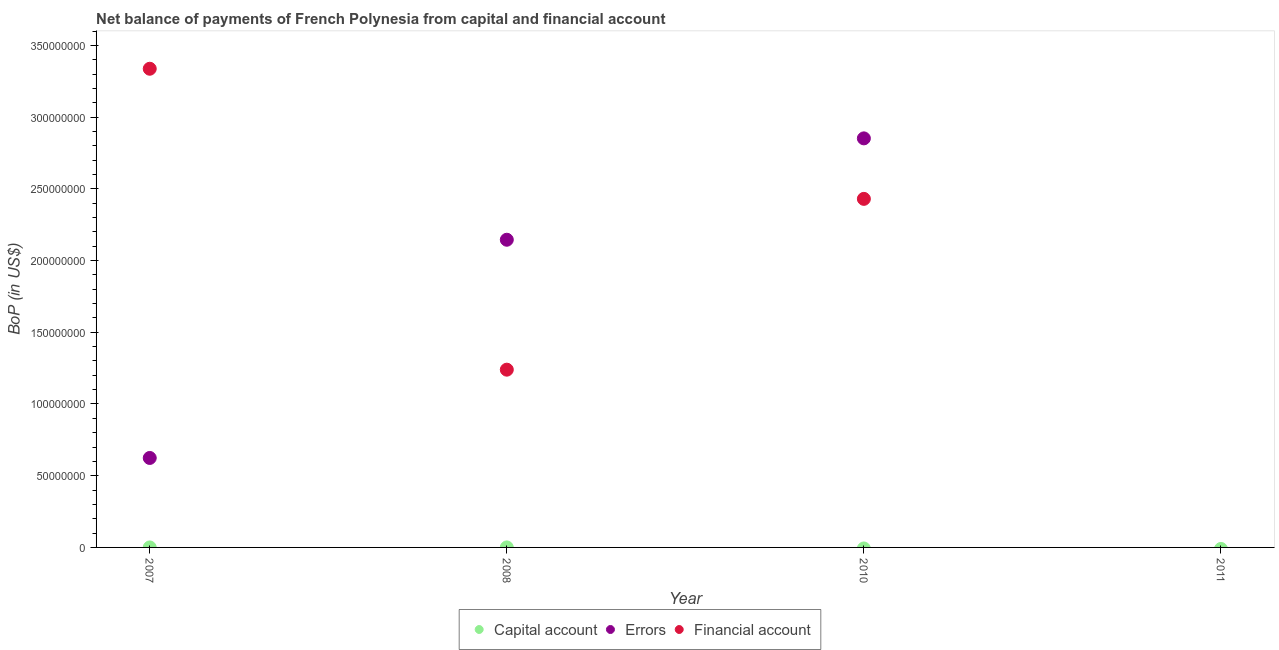Is the number of dotlines equal to the number of legend labels?
Your answer should be compact. No. Across all years, what is the maximum amount of financial account?
Keep it short and to the point. 3.34e+08. Across all years, what is the minimum amount of financial account?
Give a very brief answer. 0. What is the total amount of net capital account in the graph?
Make the answer very short. 8350.98. What is the difference between the amount of financial account in 2008 and that in 2010?
Offer a very short reply. -1.19e+08. What is the difference between the amount of financial account in 2007 and the amount of net capital account in 2010?
Give a very brief answer. 3.34e+08. What is the average amount of errors per year?
Give a very brief answer. 1.41e+08. In the year 2008, what is the difference between the amount of financial account and amount of errors?
Your answer should be very brief. -9.06e+07. What is the ratio of the amount of financial account in 2008 to that in 2010?
Offer a terse response. 0.51. What is the difference between the highest and the second highest amount of errors?
Your answer should be compact. 7.07e+07. What is the difference between the highest and the lowest amount of financial account?
Make the answer very short. 3.34e+08. Is the sum of the amount of errors in 2007 and 2010 greater than the maximum amount of financial account across all years?
Ensure brevity in your answer.  Yes. Does the amount of errors monotonically increase over the years?
Provide a succinct answer. No. Is the amount of errors strictly greater than the amount of net capital account over the years?
Your answer should be very brief. No. How many years are there in the graph?
Offer a very short reply. 4. Does the graph contain any zero values?
Make the answer very short. Yes. Does the graph contain grids?
Offer a very short reply. No. What is the title of the graph?
Keep it short and to the point. Net balance of payments of French Polynesia from capital and financial account. What is the label or title of the X-axis?
Keep it short and to the point. Year. What is the label or title of the Y-axis?
Your answer should be very brief. BoP (in US$). What is the BoP (in US$) in Errors in 2007?
Keep it short and to the point. 6.24e+07. What is the BoP (in US$) in Financial account in 2007?
Offer a very short reply. 3.34e+08. What is the BoP (in US$) in Capital account in 2008?
Your answer should be very brief. 8350.98. What is the BoP (in US$) in Errors in 2008?
Your answer should be very brief. 2.15e+08. What is the BoP (in US$) of Financial account in 2008?
Ensure brevity in your answer.  1.24e+08. What is the BoP (in US$) of Errors in 2010?
Offer a terse response. 2.85e+08. What is the BoP (in US$) of Financial account in 2010?
Ensure brevity in your answer.  2.43e+08. What is the BoP (in US$) of Capital account in 2011?
Ensure brevity in your answer.  0. What is the BoP (in US$) in Financial account in 2011?
Your answer should be very brief. 0. Across all years, what is the maximum BoP (in US$) of Capital account?
Your response must be concise. 8350.98. Across all years, what is the maximum BoP (in US$) in Errors?
Make the answer very short. 2.85e+08. Across all years, what is the maximum BoP (in US$) of Financial account?
Give a very brief answer. 3.34e+08. Across all years, what is the minimum BoP (in US$) of Capital account?
Give a very brief answer. 0. Across all years, what is the minimum BoP (in US$) in Errors?
Give a very brief answer. 0. What is the total BoP (in US$) in Capital account in the graph?
Offer a very short reply. 8350.98. What is the total BoP (in US$) in Errors in the graph?
Your answer should be very brief. 5.62e+08. What is the total BoP (in US$) in Financial account in the graph?
Give a very brief answer. 7.01e+08. What is the difference between the BoP (in US$) of Errors in 2007 and that in 2008?
Provide a succinct answer. -1.52e+08. What is the difference between the BoP (in US$) in Financial account in 2007 and that in 2008?
Make the answer very short. 2.10e+08. What is the difference between the BoP (in US$) of Errors in 2007 and that in 2010?
Keep it short and to the point. -2.23e+08. What is the difference between the BoP (in US$) in Financial account in 2007 and that in 2010?
Offer a very short reply. 9.07e+07. What is the difference between the BoP (in US$) in Errors in 2008 and that in 2010?
Keep it short and to the point. -7.07e+07. What is the difference between the BoP (in US$) in Financial account in 2008 and that in 2010?
Ensure brevity in your answer.  -1.19e+08. What is the difference between the BoP (in US$) in Errors in 2007 and the BoP (in US$) in Financial account in 2008?
Provide a short and direct response. -6.16e+07. What is the difference between the BoP (in US$) in Errors in 2007 and the BoP (in US$) in Financial account in 2010?
Offer a very short reply. -1.81e+08. What is the difference between the BoP (in US$) in Capital account in 2008 and the BoP (in US$) in Errors in 2010?
Your response must be concise. -2.85e+08. What is the difference between the BoP (in US$) of Capital account in 2008 and the BoP (in US$) of Financial account in 2010?
Keep it short and to the point. -2.43e+08. What is the difference between the BoP (in US$) in Errors in 2008 and the BoP (in US$) in Financial account in 2010?
Provide a succinct answer. -2.85e+07. What is the average BoP (in US$) of Capital account per year?
Provide a succinct answer. 2087.74. What is the average BoP (in US$) in Errors per year?
Your answer should be compact. 1.41e+08. What is the average BoP (in US$) of Financial account per year?
Make the answer very short. 1.75e+08. In the year 2007, what is the difference between the BoP (in US$) of Errors and BoP (in US$) of Financial account?
Keep it short and to the point. -2.71e+08. In the year 2008, what is the difference between the BoP (in US$) of Capital account and BoP (in US$) of Errors?
Give a very brief answer. -2.15e+08. In the year 2008, what is the difference between the BoP (in US$) of Capital account and BoP (in US$) of Financial account?
Provide a short and direct response. -1.24e+08. In the year 2008, what is the difference between the BoP (in US$) in Errors and BoP (in US$) in Financial account?
Provide a succinct answer. 9.06e+07. In the year 2010, what is the difference between the BoP (in US$) of Errors and BoP (in US$) of Financial account?
Offer a very short reply. 4.22e+07. What is the ratio of the BoP (in US$) of Errors in 2007 to that in 2008?
Offer a terse response. 0.29. What is the ratio of the BoP (in US$) in Financial account in 2007 to that in 2008?
Ensure brevity in your answer.  2.69. What is the ratio of the BoP (in US$) of Errors in 2007 to that in 2010?
Offer a very short reply. 0.22. What is the ratio of the BoP (in US$) in Financial account in 2007 to that in 2010?
Offer a terse response. 1.37. What is the ratio of the BoP (in US$) in Errors in 2008 to that in 2010?
Provide a short and direct response. 0.75. What is the ratio of the BoP (in US$) of Financial account in 2008 to that in 2010?
Your answer should be compact. 0.51. What is the difference between the highest and the second highest BoP (in US$) of Errors?
Give a very brief answer. 7.07e+07. What is the difference between the highest and the second highest BoP (in US$) of Financial account?
Provide a succinct answer. 9.07e+07. What is the difference between the highest and the lowest BoP (in US$) in Capital account?
Offer a very short reply. 8350.98. What is the difference between the highest and the lowest BoP (in US$) in Errors?
Your answer should be compact. 2.85e+08. What is the difference between the highest and the lowest BoP (in US$) in Financial account?
Your answer should be compact. 3.34e+08. 